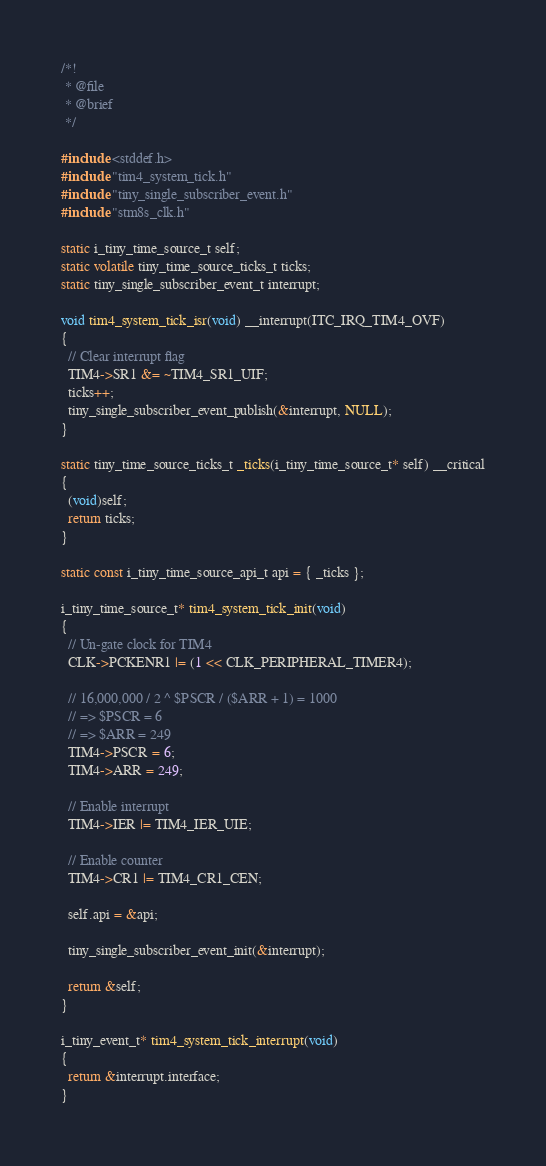<code> <loc_0><loc_0><loc_500><loc_500><_C_>/*!
 * @file
 * @brief
 */

#include <stddef.h>
#include "tim4_system_tick.h"
#include "tiny_single_subscriber_event.h"
#include "stm8s_clk.h"

static i_tiny_time_source_t self;
static volatile tiny_time_source_ticks_t ticks;
static tiny_single_subscriber_event_t interrupt;

void tim4_system_tick_isr(void) __interrupt(ITC_IRQ_TIM4_OVF)
{
  // Clear interrupt flag
  TIM4->SR1 &= ~TIM4_SR1_UIF;
  ticks++;
  tiny_single_subscriber_event_publish(&interrupt, NULL);
}

static tiny_time_source_ticks_t _ticks(i_tiny_time_source_t* self) __critical
{
  (void)self;
  return ticks;
}

static const i_tiny_time_source_api_t api = { _ticks };

i_tiny_time_source_t* tim4_system_tick_init(void)
{
  // Un-gate clock for TIM4
  CLK->PCKENR1 |= (1 << CLK_PERIPHERAL_TIMER4);

  // 16,000,000 / 2 ^ $PSCR / ($ARR + 1) = 1000
  // => $PSCR = 6
  // => $ARR = 249
  TIM4->PSCR = 6;
  TIM4->ARR = 249;

  // Enable interrupt
  TIM4->IER |= TIM4_IER_UIE;

  // Enable counter
  TIM4->CR1 |= TIM4_CR1_CEN;

  self.api = &api;

  tiny_single_subscriber_event_init(&interrupt);

  return &self;
}

i_tiny_event_t* tim4_system_tick_interrupt(void)
{
  return &interrupt.interface;
}
</code> 